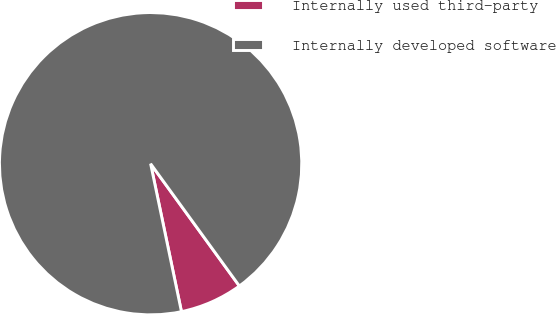Convert chart to OTSL. <chart><loc_0><loc_0><loc_500><loc_500><pie_chart><fcel>Internally used third-party<fcel>Internally developed software<nl><fcel>6.72%<fcel>93.28%<nl></chart> 